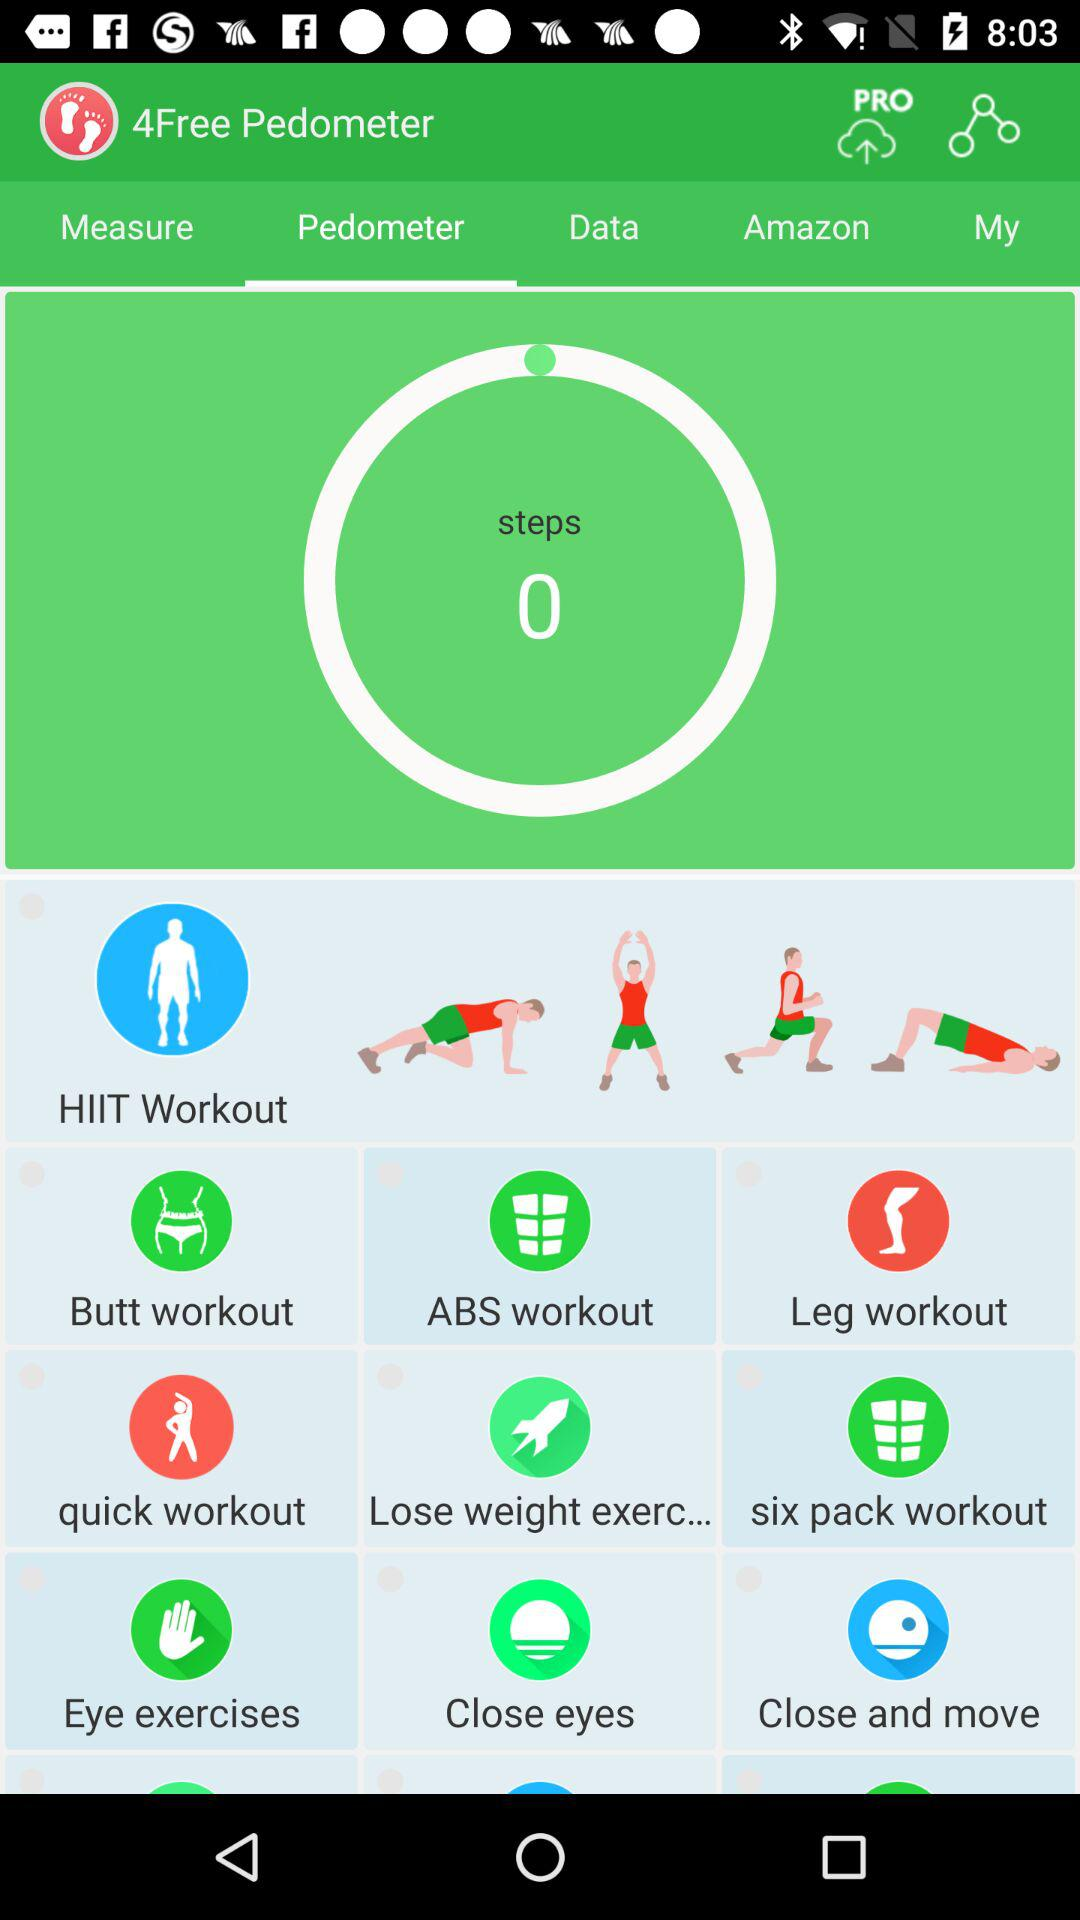What are the names of the workouts? The names of the workouts are "Butt workout", "ABS workout", "Leg workout", "quick workout", "Lose weight exerc...", "six pack workout", "Eye exercises", "Close eyes" and "Close and move". 